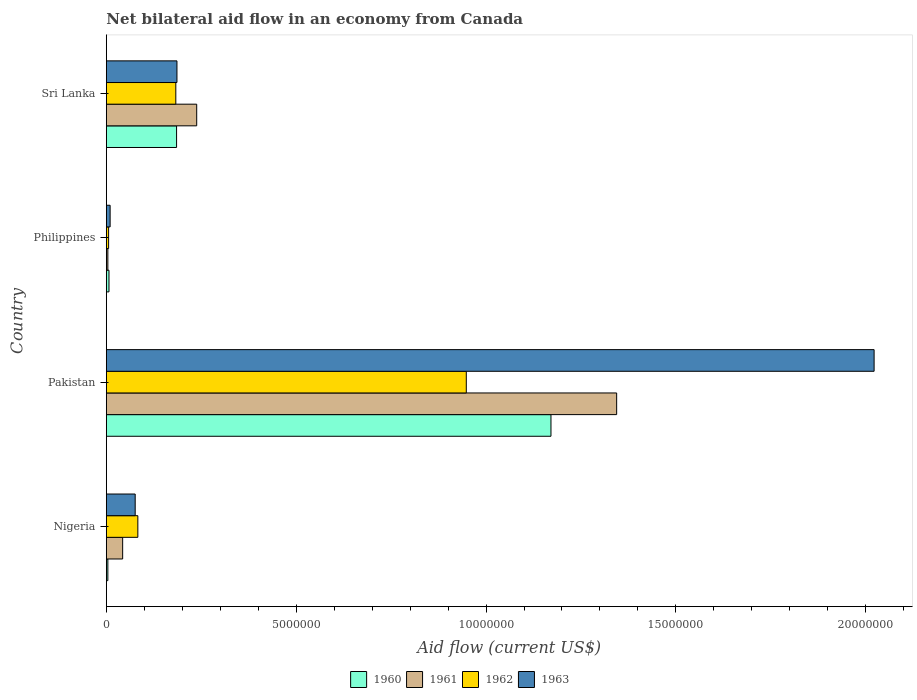How many bars are there on the 3rd tick from the top?
Provide a short and direct response. 4. What is the label of the 1st group of bars from the top?
Offer a very short reply. Sri Lanka. What is the net bilateral aid flow in 1961 in Pakistan?
Ensure brevity in your answer.  1.34e+07. Across all countries, what is the maximum net bilateral aid flow in 1963?
Offer a very short reply. 2.02e+07. Across all countries, what is the minimum net bilateral aid flow in 1961?
Ensure brevity in your answer.  4.00e+04. In which country was the net bilateral aid flow in 1963 minimum?
Ensure brevity in your answer.  Philippines. What is the total net bilateral aid flow in 1960 in the graph?
Ensure brevity in your answer.  1.37e+07. What is the difference between the net bilateral aid flow in 1960 in Nigeria and that in Pakistan?
Provide a short and direct response. -1.17e+07. What is the difference between the net bilateral aid flow in 1962 in Sri Lanka and the net bilateral aid flow in 1960 in Pakistan?
Provide a short and direct response. -9.88e+06. What is the average net bilateral aid flow in 1961 per country?
Make the answer very short. 4.07e+06. In how many countries, is the net bilateral aid flow in 1962 greater than 9000000 US$?
Offer a terse response. 1. What is the ratio of the net bilateral aid flow in 1960 in Pakistan to that in Philippines?
Your response must be concise. 167.29. Is the net bilateral aid flow in 1960 in Nigeria less than that in Pakistan?
Offer a terse response. Yes. What is the difference between the highest and the second highest net bilateral aid flow in 1961?
Your answer should be very brief. 1.11e+07. What is the difference between the highest and the lowest net bilateral aid flow in 1962?
Your answer should be very brief. 9.42e+06. What does the 4th bar from the top in Pakistan represents?
Ensure brevity in your answer.  1960. What does the 4th bar from the bottom in Pakistan represents?
Provide a short and direct response. 1963. Are all the bars in the graph horizontal?
Provide a succinct answer. Yes. How many countries are there in the graph?
Your response must be concise. 4. What is the difference between two consecutive major ticks on the X-axis?
Offer a very short reply. 5.00e+06. Where does the legend appear in the graph?
Keep it short and to the point. Bottom center. How many legend labels are there?
Make the answer very short. 4. What is the title of the graph?
Your answer should be compact. Net bilateral aid flow in an economy from Canada. What is the label or title of the X-axis?
Make the answer very short. Aid flow (current US$). What is the Aid flow (current US$) in 1961 in Nigeria?
Keep it short and to the point. 4.30e+05. What is the Aid flow (current US$) in 1962 in Nigeria?
Provide a succinct answer. 8.30e+05. What is the Aid flow (current US$) in 1963 in Nigeria?
Ensure brevity in your answer.  7.60e+05. What is the Aid flow (current US$) of 1960 in Pakistan?
Make the answer very short. 1.17e+07. What is the Aid flow (current US$) in 1961 in Pakistan?
Offer a terse response. 1.34e+07. What is the Aid flow (current US$) in 1962 in Pakistan?
Your answer should be compact. 9.48e+06. What is the Aid flow (current US$) of 1963 in Pakistan?
Offer a terse response. 2.02e+07. What is the Aid flow (current US$) of 1961 in Philippines?
Your response must be concise. 4.00e+04. What is the Aid flow (current US$) of 1962 in Philippines?
Your response must be concise. 6.00e+04. What is the Aid flow (current US$) in 1960 in Sri Lanka?
Keep it short and to the point. 1.85e+06. What is the Aid flow (current US$) in 1961 in Sri Lanka?
Offer a very short reply. 2.38e+06. What is the Aid flow (current US$) of 1962 in Sri Lanka?
Offer a terse response. 1.83e+06. What is the Aid flow (current US$) of 1963 in Sri Lanka?
Ensure brevity in your answer.  1.86e+06. Across all countries, what is the maximum Aid flow (current US$) of 1960?
Provide a short and direct response. 1.17e+07. Across all countries, what is the maximum Aid flow (current US$) in 1961?
Offer a very short reply. 1.34e+07. Across all countries, what is the maximum Aid flow (current US$) of 1962?
Keep it short and to the point. 9.48e+06. Across all countries, what is the maximum Aid flow (current US$) of 1963?
Your response must be concise. 2.02e+07. Across all countries, what is the minimum Aid flow (current US$) of 1961?
Keep it short and to the point. 4.00e+04. Across all countries, what is the minimum Aid flow (current US$) of 1962?
Give a very brief answer. 6.00e+04. Across all countries, what is the minimum Aid flow (current US$) of 1963?
Your answer should be very brief. 1.00e+05. What is the total Aid flow (current US$) of 1960 in the graph?
Provide a succinct answer. 1.37e+07. What is the total Aid flow (current US$) in 1961 in the graph?
Your response must be concise. 1.63e+07. What is the total Aid flow (current US$) of 1962 in the graph?
Your answer should be very brief. 1.22e+07. What is the total Aid flow (current US$) of 1963 in the graph?
Your answer should be compact. 2.29e+07. What is the difference between the Aid flow (current US$) of 1960 in Nigeria and that in Pakistan?
Your answer should be compact. -1.17e+07. What is the difference between the Aid flow (current US$) of 1961 in Nigeria and that in Pakistan?
Your answer should be compact. -1.30e+07. What is the difference between the Aid flow (current US$) of 1962 in Nigeria and that in Pakistan?
Provide a succinct answer. -8.65e+06. What is the difference between the Aid flow (current US$) in 1963 in Nigeria and that in Pakistan?
Your response must be concise. -1.95e+07. What is the difference between the Aid flow (current US$) of 1960 in Nigeria and that in Philippines?
Your response must be concise. -3.00e+04. What is the difference between the Aid flow (current US$) of 1962 in Nigeria and that in Philippines?
Provide a short and direct response. 7.70e+05. What is the difference between the Aid flow (current US$) in 1960 in Nigeria and that in Sri Lanka?
Your answer should be compact. -1.81e+06. What is the difference between the Aid flow (current US$) of 1961 in Nigeria and that in Sri Lanka?
Make the answer very short. -1.95e+06. What is the difference between the Aid flow (current US$) of 1963 in Nigeria and that in Sri Lanka?
Your answer should be compact. -1.10e+06. What is the difference between the Aid flow (current US$) in 1960 in Pakistan and that in Philippines?
Keep it short and to the point. 1.16e+07. What is the difference between the Aid flow (current US$) in 1961 in Pakistan and that in Philippines?
Make the answer very short. 1.34e+07. What is the difference between the Aid flow (current US$) in 1962 in Pakistan and that in Philippines?
Provide a succinct answer. 9.42e+06. What is the difference between the Aid flow (current US$) in 1963 in Pakistan and that in Philippines?
Provide a succinct answer. 2.01e+07. What is the difference between the Aid flow (current US$) in 1960 in Pakistan and that in Sri Lanka?
Your response must be concise. 9.86e+06. What is the difference between the Aid flow (current US$) in 1961 in Pakistan and that in Sri Lanka?
Give a very brief answer. 1.11e+07. What is the difference between the Aid flow (current US$) of 1962 in Pakistan and that in Sri Lanka?
Your answer should be compact. 7.65e+06. What is the difference between the Aid flow (current US$) of 1963 in Pakistan and that in Sri Lanka?
Offer a terse response. 1.84e+07. What is the difference between the Aid flow (current US$) in 1960 in Philippines and that in Sri Lanka?
Provide a succinct answer. -1.78e+06. What is the difference between the Aid flow (current US$) of 1961 in Philippines and that in Sri Lanka?
Your answer should be very brief. -2.34e+06. What is the difference between the Aid flow (current US$) in 1962 in Philippines and that in Sri Lanka?
Provide a succinct answer. -1.77e+06. What is the difference between the Aid flow (current US$) of 1963 in Philippines and that in Sri Lanka?
Make the answer very short. -1.76e+06. What is the difference between the Aid flow (current US$) of 1960 in Nigeria and the Aid flow (current US$) of 1961 in Pakistan?
Provide a succinct answer. -1.34e+07. What is the difference between the Aid flow (current US$) of 1960 in Nigeria and the Aid flow (current US$) of 1962 in Pakistan?
Provide a succinct answer. -9.44e+06. What is the difference between the Aid flow (current US$) of 1960 in Nigeria and the Aid flow (current US$) of 1963 in Pakistan?
Provide a short and direct response. -2.02e+07. What is the difference between the Aid flow (current US$) in 1961 in Nigeria and the Aid flow (current US$) in 1962 in Pakistan?
Offer a very short reply. -9.05e+06. What is the difference between the Aid flow (current US$) of 1961 in Nigeria and the Aid flow (current US$) of 1963 in Pakistan?
Give a very brief answer. -1.98e+07. What is the difference between the Aid flow (current US$) of 1962 in Nigeria and the Aid flow (current US$) of 1963 in Pakistan?
Your answer should be very brief. -1.94e+07. What is the difference between the Aid flow (current US$) in 1960 in Nigeria and the Aid flow (current US$) in 1961 in Philippines?
Offer a terse response. 0. What is the difference between the Aid flow (current US$) of 1960 in Nigeria and the Aid flow (current US$) of 1963 in Philippines?
Provide a succinct answer. -6.00e+04. What is the difference between the Aid flow (current US$) in 1961 in Nigeria and the Aid flow (current US$) in 1962 in Philippines?
Provide a succinct answer. 3.70e+05. What is the difference between the Aid flow (current US$) in 1961 in Nigeria and the Aid flow (current US$) in 1963 in Philippines?
Make the answer very short. 3.30e+05. What is the difference between the Aid flow (current US$) of 1962 in Nigeria and the Aid flow (current US$) of 1963 in Philippines?
Give a very brief answer. 7.30e+05. What is the difference between the Aid flow (current US$) of 1960 in Nigeria and the Aid flow (current US$) of 1961 in Sri Lanka?
Ensure brevity in your answer.  -2.34e+06. What is the difference between the Aid flow (current US$) in 1960 in Nigeria and the Aid flow (current US$) in 1962 in Sri Lanka?
Give a very brief answer. -1.79e+06. What is the difference between the Aid flow (current US$) of 1960 in Nigeria and the Aid flow (current US$) of 1963 in Sri Lanka?
Offer a terse response. -1.82e+06. What is the difference between the Aid flow (current US$) in 1961 in Nigeria and the Aid flow (current US$) in 1962 in Sri Lanka?
Make the answer very short. -1.40e+06. What is the difference between the Aid flow (current US$) of 1961 in Nigeria and the Aid flow (current US$) of 1963 in Sri Lanka?
Provide a short and direct response. -1.43e+06. What is the difference between the Aid flow (current US$) in 1962 in Nigeria and the Aid flow (current US$) in 1963 in Sri Lanka?
Provide a succinct answer. -1.03e+06. What is the difference between the Aid flow (current US$) in 1960 in Pakistan and the Aid flow (current US$) in 1961 in Philippines?
Offer a terse response. 1.17e+07. What is the difference between the Aid flow (current US$) of 1960 in Pakistan and the Aid flow (current US$) of 1962 in Philippines?
Provide a short and direct response. 1.16e+07. What is the difference between the Aid flow (current US$) in 1960 in Pakistan and the Aid flow (current US$) in 1963 in Philippines?
Make the answer very short. 1.16e+07. What is the difference between the Aid flow (current US$) in 1961 in Pakistan and the Aid flow (current US$) in 1962 in Philippines?
Your answer should be compact. 1.34e+07. What is the difference between the Aid flow (current US$) of 1961 in Pakistan and the Aid flow (current US$) of 1963 in Philippines?
Provide a short and direct response. 1.33e+07. What is the difference between the Aid flow (current US$) of 1962 in Pakistan and the Aid flow (current US$) of 1963 in Philippines?
Offer a very short reply. 9.38e+06. What is the difference between the Aid flow (current US$) in 1960 in Pakistan and the Aid flow (current US$) in 1961 in Sri Lanka?
Give a very brief answer. 9.33e+06. What is the difference between the Aid flow (current US$) of 1960 in Pakistan and the Aid flow (current US$) of 1962 in Sri Lanka?
Your response must be concise. 9.88e+06. What is the difference between the Aid flow (current US$) of 1960 in Pakistan and the Aid flow (current US$) of 1963 in Sri Lanka?
Your answer should be very brief. 9.85e+06. What is the difference between the Aid flow (current US$) in 1961 in Pakistan and the Aid flow (current US$) in 1962 in Sri Lanka?
Your answer should be very brief. 1.16e+07. What is the difference between the Aid flow (current US$) in 1961 in Pakistan and the Aid flow (current US$) in 1963 in Sri Lanka?
Your response must be concise. 1.16e+07. What is the difference between the Aid flow (current US$) of 1962 in Pakistan and the Aid flow (current US$) of 1963 in Sri Lanka?
Provide a succinct answer. 7.62e+06. What is the difference between the Aid flow (current US$) of 1960 in Philippines and the Aid flow (current US$) of 1961 in Sri Lanka?
Make the answer very short. -2.31e+06. What is the difference between the Aid flow (current US$) of 1960 in Philippines and the Aid flow (current US$) of 1962 in Sri Lanka?
Provide a short and direct response. -1.76e+06. What is the difference between the Aid flow (current US$) of 1960 in Philippines and the Aid flow (current US$) of 1963 in Sri Lanka?
Give a very brief answer. -1.79e+06. What is the difference between the Aid flow (current US$) of 1961 in Philippines and the Aid flow (current US$) of 1962 in Sri Lanka?
Offer a very short reply. -1.79e+06. What is the difference between the Aid flow (current US$) of 1961 in Philippines and the Aid flow (current US$) of 1963 in Sri Lanka?
Offer a very short reply. -1.82e+06. What is the difference between the Aid flow (current US$) of 1962 in Philippines and the Aid flow (current US$) of 1963 in Sri Lanka?
Make the answer very short. -1.80e+06. What is the average Aid flow (current US$) in 1960 per country?
Provide a succinct answer. 3.42e+06. What is the average Aid flow (current US$) in 1961 per country?
Make the answer very short. 4.07e+06. What is the average Aid flow (current US$) of 1962 per country?
Give a very brief answer. 3.05e+06. What is the average Aid flow (current US$) of 1963 per country?
Your response must be concise. 5.74e+06. What is the difference between the Aid flow (current US$) of 1960 and Aid flow (current US$) of 1961 in Nigeria?
Provide a succinct answer. -3.90e+05. What is the difference between the Aid flow (current US$) of 1960 and Aid flow (current US$) of 1962 in Nigeria?
Offer a very short reply. -7.90e+05. What is the difference between the Aid flow (current US$) in 1960 and Aid flow (current US$) in 1963 in Nigeria?
Give a very brief answer. -7.20e+05. What is the difference between the Aid flow (current US$) of 1961 and Aid flow (current US$) of 1962 in Nigeria?
Make the answer very short. -4.00e+05. What is the difference between the Aid flow (current US$) of 1961 and Aid flow (current US$) of 1963 in Nigeria?
Provide a short and direct response. -3.30e+05. What is the difference between the Aid flow (current US$) in 1960 and Aid flow (current US$) in 1961 in Pakistan?
Make the answer very short. -1.73e+06. What is the difference between the Aid flow (current US$) in 1960 and Aid flow (current US$) in 1962 in Pakistan?
Offer a terse response. 2.23e+06. What is the difference between the Aid flow (current US$) of 1960 and Aid flow (current US$) of 1963 in Pakistan?
Ensure brevity in your answer.  -8.51e+06. What is the difference between the Aid flow (current US$) of 1961 and Aid flow (current US$) of 1962 in Pakistan?
Offer a terse response. 3.96e+06. What is the difference between the Aid flow (current US$) in 1961 and Aid flow (current US$) in 1963 in Pakistan?
Ensure brevity in your answer.  -6.78e+06. What is the difference between the Aid flow (current US$) of 1962 and Aid flow (current US$) of 1963 in Pakistan?
Your answer should be very brief. -1.07e+07. What is the difference between the Aid flow (current US$) in 1960 and Aid flow (current US$) in 1961 in Philippines?
Your response must be concise. 3.00e+04. What is the difference between the Aid flow (current US$) in 1960 and Aid flow (current US$) in 1962 in Philippines?
Provide a succinct answer. 10000. What is the difference between the Aid flow (current US$) of 1961 and Aid flow (current US$) of 1962 in Philippines?
Ensure brevity in your answer.  -2.00e+04. What is the difference between the Aid flow (current US$) in 1962 and Aid flow (current US$) in 1963 in Philippines?
Offer a terse response. -4.00e+04. What is the difference between the Aid flow (current US$) of 1960 and Aid flow (current US$) of 1961 in Sri Lanka?
Your answer should be very brief. -5.30e+05. What is the difference between the Aid flow (current US$) in 1960 and Aid flow (current US$) in 1962 in Sri Lanka?
Your answer should be very brief. 2.00e+04. What is the difference between the Aid flow (current US$) in 1961 and Aid flow (current US$) in 1963 in Sri Lanka?
Provide a short and direct response. 5.20e+05. What is the ratio of the Aid flow (current US$) in 1960 in Nigeria to that in Pakistan?
Your answer should be very brief. 0. What is the ratio of the Aid flow (current US$) of 1961 in Nigeria to that in Pakistan?
Offer a very short reply. 0.03. What is the ratio of the Aid flow (current US$) of 1962 in Nigeria to that in Pakistan?
Make the answer very short. 0.09. What is the ratio of the Aid flow (current US$) of 1963 in Nigeria to that in Pakistan?
Your answer should be very brief. 0.04. What is the ratio of the Aid flow (current US$) in 1961 in Nigeria to that in Philippines?
Your response must be concise. 10.75. What is the ratio of the Aid flow (current US$) of 1962 in Nigeria to that in Philippines?
Provide a succinct answer. 13.83. What is the ratio of the Aid flow (current US$) of 1960 in Nigeria to that in Sri Lanka?
Keep it short and to the point. 0.02. What is the ratio of the Aid flow (current US$) in 1961 in Nigeria to that in Sri Lanka?
Offer a terse response. 0.18. What is the ratio of the Aid flow (current US$) of 1962 in Nigeria to that in Sri Lanka?
Give a very brief answer. 0.45. What is the ratio of the Aid flow (current US$) in 1963 in Nigeria to that in Sri Lanka?
Offer a very short reply. 0.41. What is the ratio of the Aid flow (current US$) of 1960 in Pakistan to that in Philippines?
Keep it short and to the point. 167.29. What is the ratio of the Aid flow (current US$) of 1961 in Pakistan to that in Philippines?
Offer a very short reply. 336. What is the ratio of the Aid flow (current US$) of 1962 in Pakistan to that in Philippines?
Offer a terse response. 158. What is the ratio of the Aid flow (current US$) of 1963 in Pakistan to that in Philippines?
Provide a succinct answer. 202.2. What is the ratio of the Aid flow (current US$) in 1960 in Pakistan to that in Sri Lanka?
Give a very brief answer. 6.33. What is the ratio of the Aid flow (current US$) of 1961 in Pakistan to that in Sri Lanka?
Your answer should be very brief. 5.65. What is the ratio of the Aid flow (current US$) in 1962 in Pakistan to that in Sri Lanka?
Your answer should be very brief. 5.18. What is the ratio of the Aid flow (current US$) in 1963 in Pakistan to that in Sri Lanka?
Your response must be concise. 10.87. What is the ratio of the Aid flow (current US$) of 1960 in Philippines to that in Sri Lanka?
Your response must be concise. 0.04. What is the ratio of the Aid flow (current US$) of 1961 in Philippines to that in Sri Lanka?
Your answer should be very brief. 0.02. What is the ratio of the Aid flow (current US$) of 1962 in Philippines to that in Sri Lanka?
Make the answer very short. 0.03. What is the ratio of the Aid flow (current US$) in 1963 in Philippines to that in Sri Lanka?
Ensure brevity in your answer.  0.05. What is the difference between the highest and the second highest Aid flow (current US$) of 1960?
Offer a terse response. 9.86e+06. What is the difference between the highest and the second highest Aid flow (current US$) of 1961?
Make the answer very short. 1.11e+07. What is the difference between the highest and the second highest Aid flow (current US$) in 1962?
Your answer should be compact. 7.65e+06. What is the difference between the highest and the second highest Aid flow (current US$) in 1963?
Offer a terse response. 1.84e+07. What is the difference between the highest and the lowest Aid flow (current US$) of 1960?
Ensure brevity in your answer.  1.17e+07. What is the difference between the highest and the lowest Aid flow (current US$) in 1961?
Provide a succinct answer. 1.34e+07. What is the difference between the highest and the lowest Aid flow (current US$) in 1962?
Provide a succinct answer. 9.42e+06. What is the difference between the highest and the lowest Aid flow (current US$) in 1963?
Your answer should be compact. 2.01e+07. 